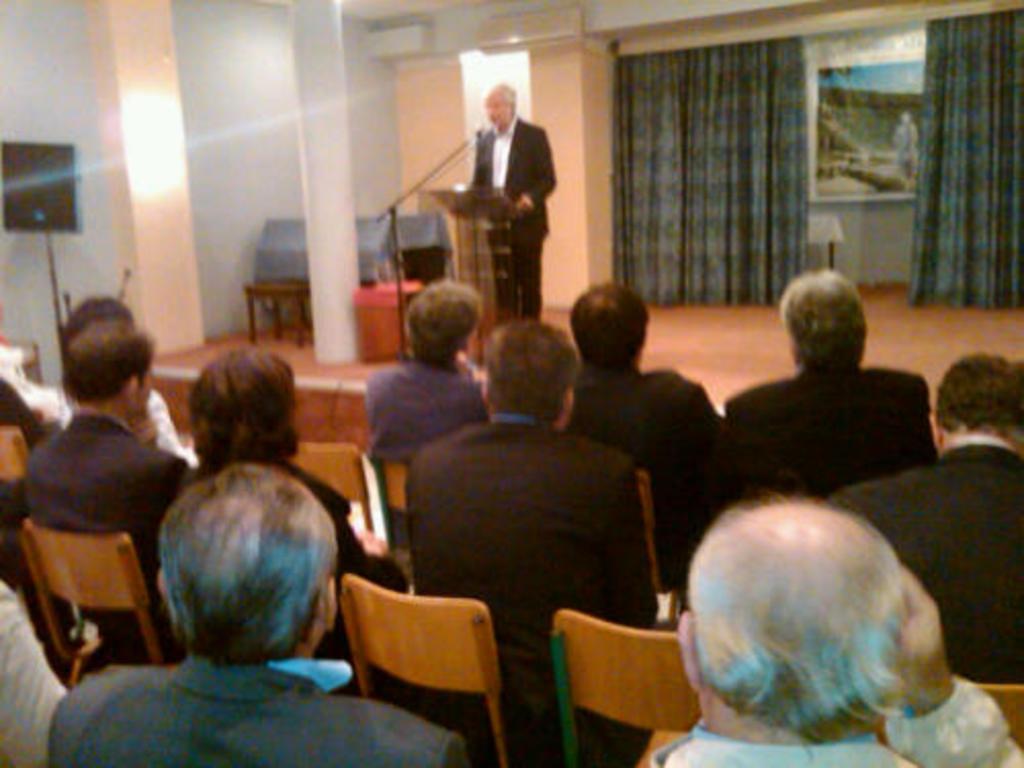Can you describe this image briefly? A picture inside of a room. These persons are sitting on a chair. This person is standing. In-front of this person there is a podium with mic. This is curtain. A poster on wall. 